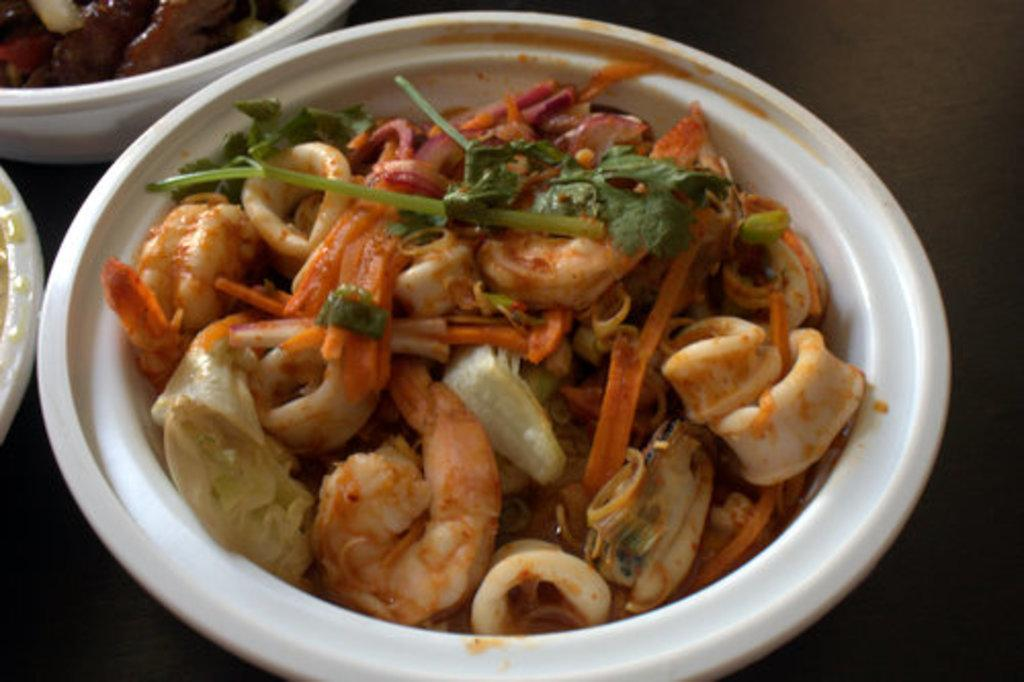What color is the bowl that contains food items in the image? The bowl is white. What can be found inside the white bowl in the image? There are food items in the white bowl. Are there any other bowls with food items in the image? Yes, there is another food item on a white bowl in the top left of the image. How many legs does the bowl have in the image? Bowls do not have legs; they are stationary objects. 